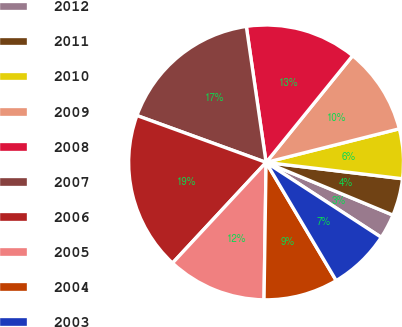<chart> <loc_0><loc_0><loc_500><loc_500><pie_chart><fcel>2012<fcel>2011<fcel>2010<fcel>2009<fcel>2008<fcel>2007<fcel>2006<fcel>2005<fcel>2004<fcel>2003<nl><fcel>2.91%<fcel>4.37%<fcel>5.83%<fcel>10.22%<fcel>13.14%<fcel>17.16%<fcel>18.62%<fcel>11.68%<fcel>8.76%<fcel>7.3%<nl></chart> 